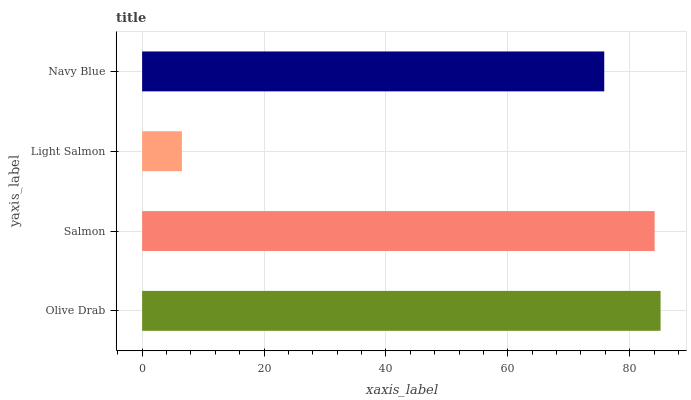Is Light Salmon the minimum?
Answer yes or no. Yes. Is Olive Drab the maximum?
Answer yes or no. Yes. Is Salmon the minimum?
Answer yes or no. No. Is Salmon the maximum?
Answer yes or no. No. Is Olive Drab greater than Salmon?
Answer yes or no. Yes. Is Salmon less than Olive Drab?
Answer yes or no. Yes. Is Salmon greater than Olive Drab?
Answer yes or no. No. Is Olive Drab less than Salmon?
Answer yes or no. No. Is Salmon the high median?
Answer yes or no. Yes. Is Navy Blue the low median?
Answer yes or no. Yes. Is Light Salmon the high median?
Answer yes or no. No. Is Olive Drab the low median?
Answer yes or no. No. 